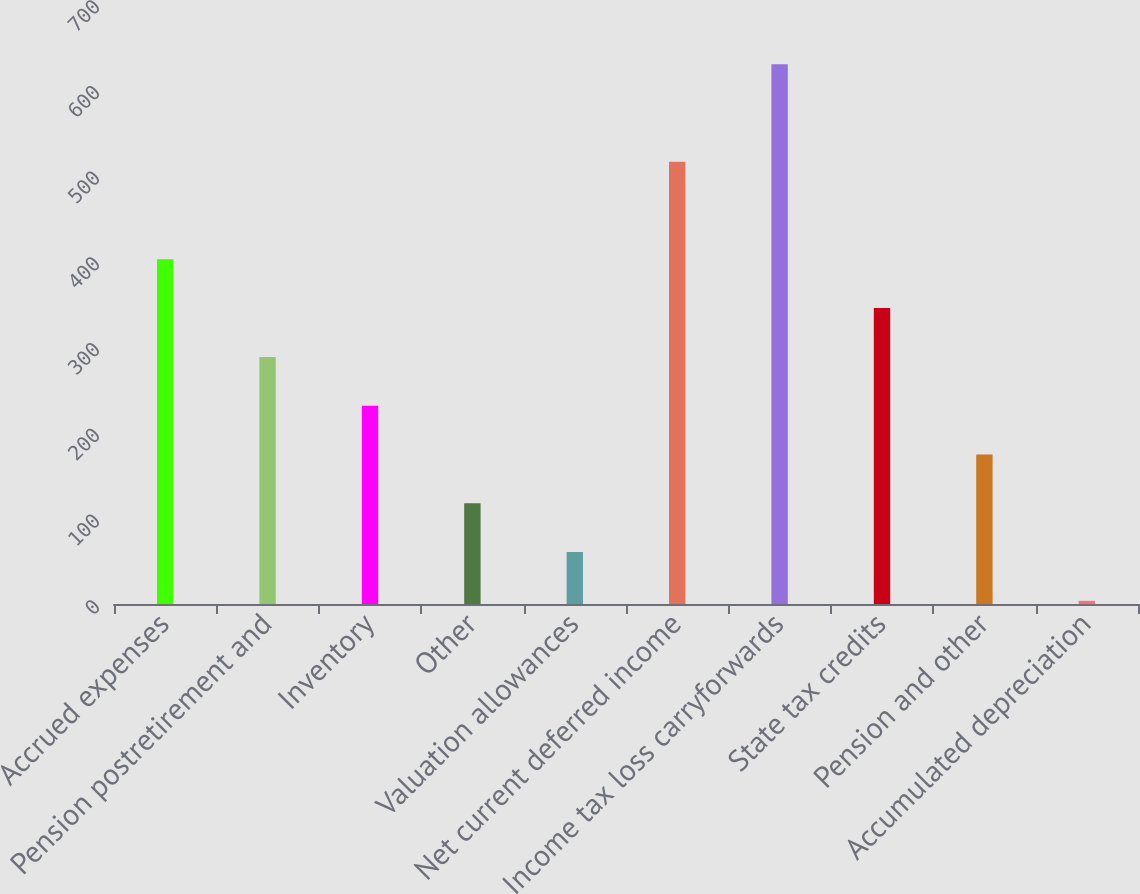Convert chart. <chart><loc_0><loc_0><loc_500><loc_500><bar_chart><fcel>Accrued expenses<fcel>Pension postretirement and<fcel>Inventory<fcel>Other<fcel>Valuation allowances<fcel>Net current deferred income<fcel>Income tax loss carryforwards<fcel>State tax credits<fcel>Pension and other<fcel>Accumulated depreciation<nl><fcel>402.14<fcel>288.3<fcel>231.38<fcel>117.54<fcel>60.62<fcel>515.98<fcel>629.82<fcel>345.22<fcel>174.46<fcel>3.7<nl></chart> 